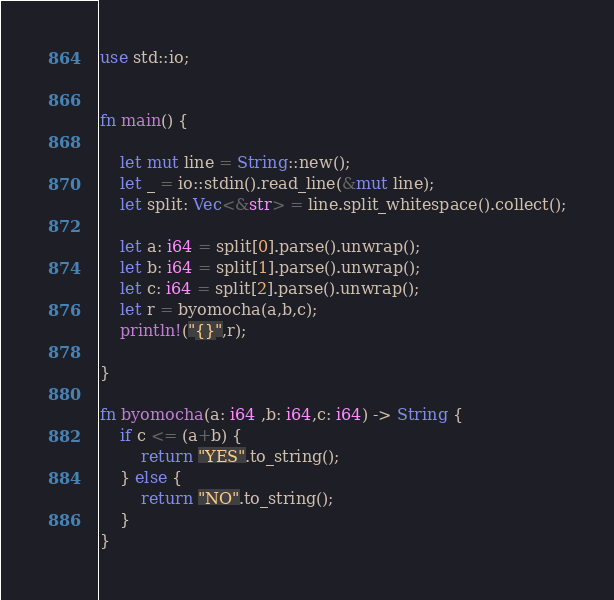<code> <loc_0><loc_0><loc_500><loc_500><_Rust_>use std::io;


fn main() {

    let mut line = String::new();
    let _ = io::stdin().read_line(&mut line);
    let split: Vec<&str> = line.split_whitespace().collect();

    let a: i64 = split[0].parse().unwrap();
    let b: i64 = split[1].parse().unwrap();
    let c: i64 = split[2].parse().unwrap();
    let r = byomocha(a,b,c);
    println!("{}",r);

}

fn byomocha(a: i64 ,b: i64,c: i64) -> String {
    if c <= (a+b) {
        return "YES".to_string();
    } else {
        return "NO".to_string();
    }
}</code> 